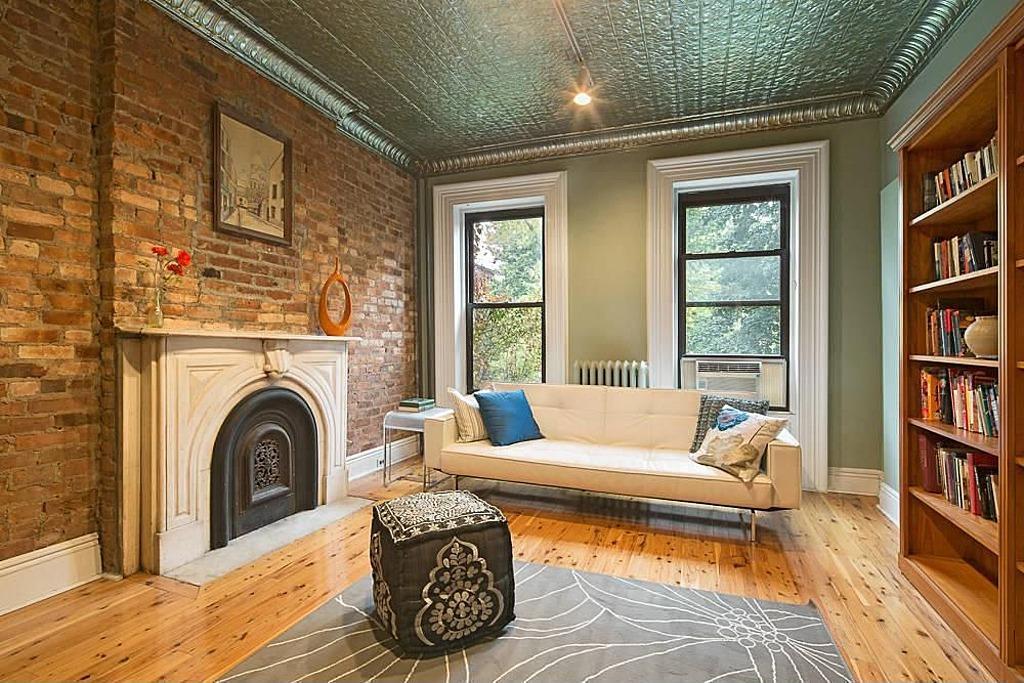Please provide a concise description of this image. This is a room. Inside the room there is a sofa. On sofa there are pillows. There is a table. On the left side there is a brick wall with a photo frame. There is a cupboard. On the cupboard there is a photo frame. On the right side there is a cupboard inside the cupboard there are books. In the back there are windows. On the ceiling there is a light. 